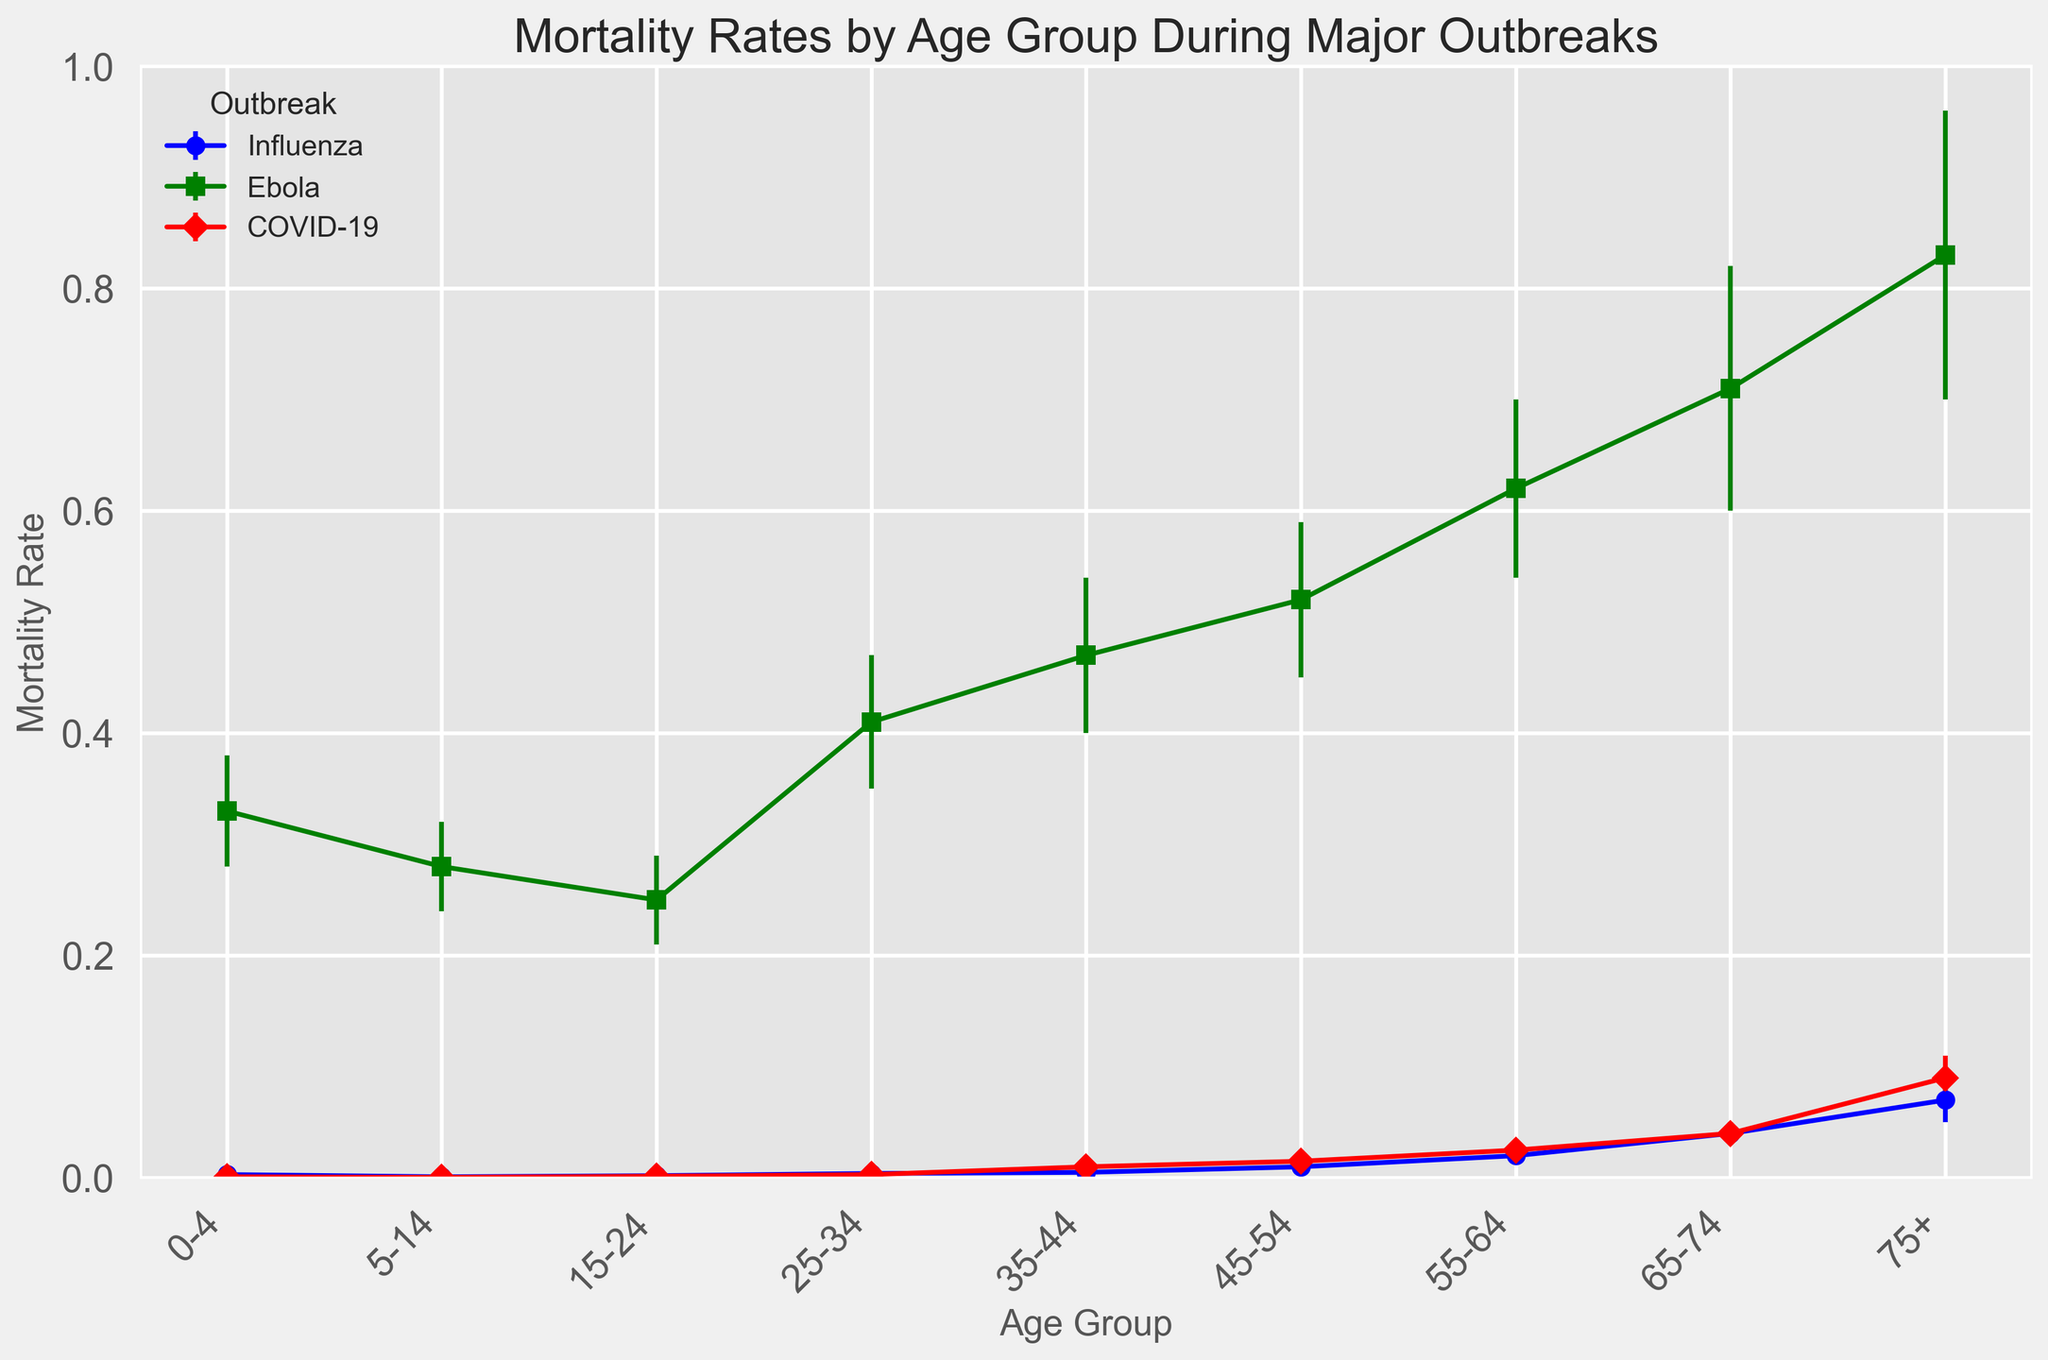What is the mortality rate for the age group 75+ during the COVID-19 outbreak? According to the figure, the red marker representing COVID-19 shows a mortality rate for the age group 75+ at the top right. The exact mortality rate value is provided near the axis.
Answer: 0.09 Which age group had the highest mortality rate during the Ebola outbreak? The green markers represent the Ebola outbreak. Scan through the green markers across all age groups to find the highest value, which corresponds to the 75+ age group.
Answer: 75+ How does the mortality rate for the age group 55-64 compare between Influenza and COVID-19 outbreaks? Locate the markers for the 55-64 age group for both blue (Influenza) and red (COVID-19). Compare their heights directly.
Answer: Higher for Influenza (0.02 for Influenza vs 0.025 for COVID-19) What's the average mortality rate for age groups 25-34 and 35-44 during the Influenza outbreak? To find the average, sum the mortality rates of the 25-34 and 35-44 age groups for Influenza and then divide by 2. (0.004 + 0.005)/2 = 0.0045
Answer: 0.0045 Which outbreak had the lowest mortality rate for the age group 5-14? Identify the markers for the age group 5-14 across all outbreaks and find the lowest value. The red marker representing COVID-19 has the lowest mortality rate.
Answer: COVID-19 Compare the error margins for age group 0-4 between Influenza and Ebola. Which outbreak has a larger error margin? The error bars for the age group 0-4 for both blue (Influenza) and green (Ebola) markers need to be compared. Ebola has a larger error margin of 0.05 compared to Influenza's 0.001.
Answer: Ebola What is the trend in mortality rates for the Influenza outbreak as age groups increase? Look at the series of blue markers representing Influenza from left to right. The mortality rates increase consistently as age groups rise.
Answer: Increasing trend What is the difference in mortality rates between the 35-44 and 55-64 age groups during the Ebola outbreak? Subtract the mortality rate of the 35-44 age group from the 55-64 age group for the green markers. 0.62 - 0.47 = 0.15
Answer: 0.15 How do the mortality rates for the 25-34 age group compare across all three outbreaks? Examine the markers for the 25-34 age group indicated by blue (Influenza), green (Ebola), and red (COVID-19). Compare their heights directly.
Answer: Ebola > Influenza > COVID-19 